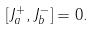<formula> <loc_0><loc_0><loc_500><loc_500>[ J ^ { + } _ { a } , J ^ { - } _ { b } ] = 0 .</formula> 